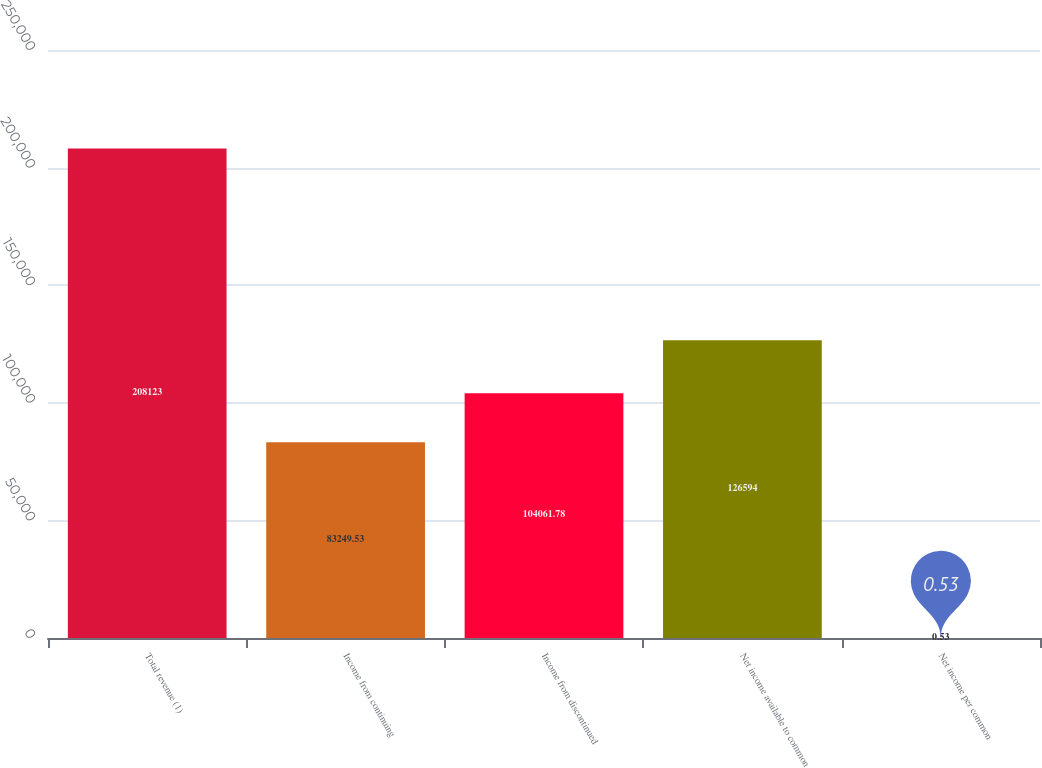Convert chart. <chart><loc_0><loc_0><loc_500><loc_500><bar_chart><fcel>Total revenue (1)<fcel>Income from continuing<fcel>Income from discontinued<fcel>Net income available to common<fcel>Net income per common<nl><fcel>208123<fcel>83249.5<fcel>104062<fcel>126594<fcel>0.53<nl></chart> 